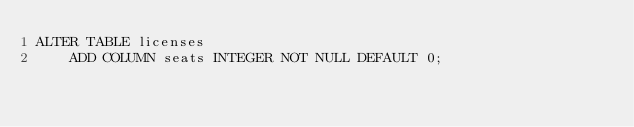<code> <loc_0><loc_0><loc_500><loc_500><_SQL_>ALTER TABLE licenses 
    ADD COLUMN seats INTEGER NOT NULL DEFAULT 0;
</code> 